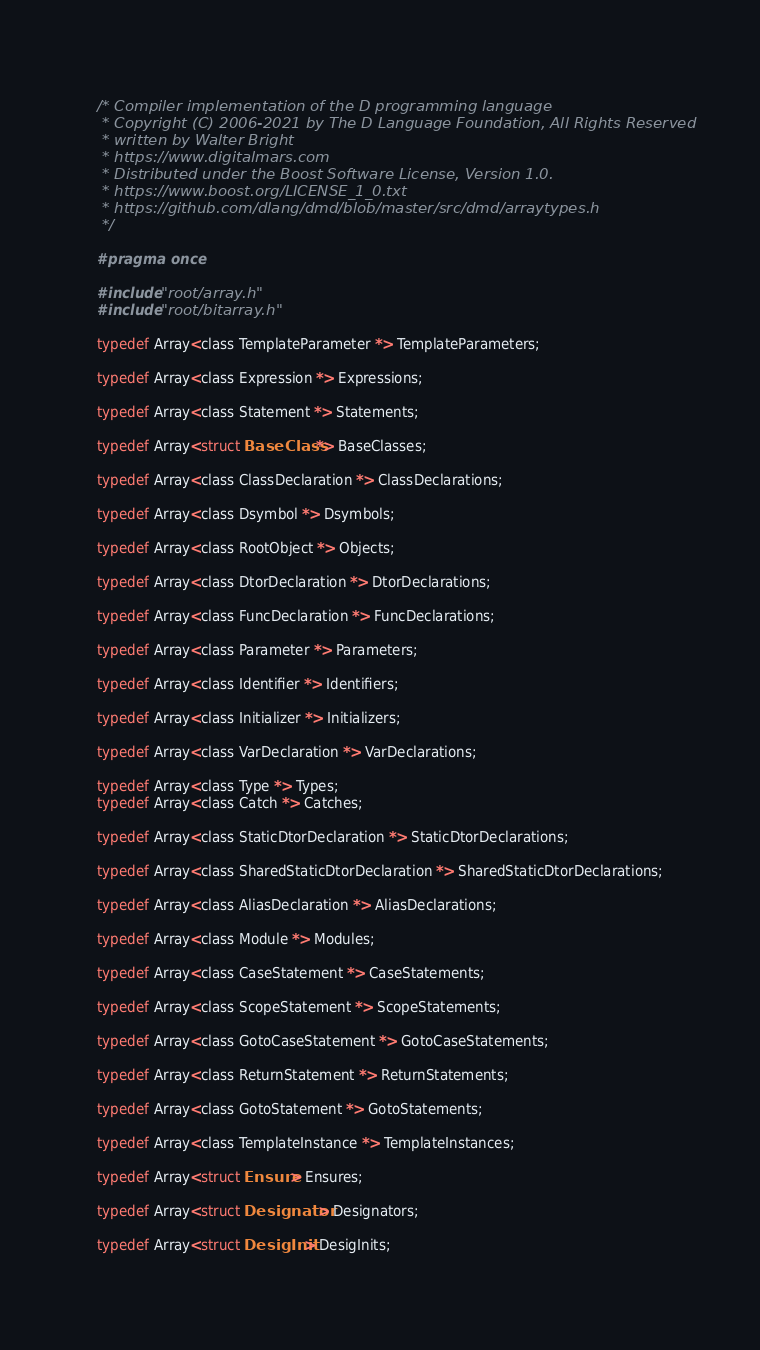Convert code to text. <code><loc_0><loc_0><loc_500><loc_500><_C_>
/* Compiler implementation of the D programming language
 * Copyright (C) 2006-2021 by The D Language Foundation, All Rights Reserved
 * written by Walter Bright
 * https://www.digitalmars.com
 * Distributed under the Boost Software License, Version 1.0.
 * https://www.boost.org/LICENSE_1_0.txt
 * https://github.com/dlang/dmd/blob/master/src/dmd/arraytypes.h
 */

#pragma once

#include "root/array.h"
#include "root/bitarray.h"

typedef Array<class TemplateParameter *> TemplateParameters;

typedef Array<class Expression *> Expressions;

typedef Array<class Statement *> Statements;

typedef Array<struct BaseClass *> BaseClasses;

typedef Array<class ClassDeclaration *> ClassDeclarations;

typedef Array<class Dsymbol *> Dsymbols;

typedef Array<class RootObject *> Objects;

typedef Array<class DtorDeclaration *> DtorDeclarations;

typedef Array<class FuncDeclaration *> FuncDeclarations;

typedef Array<class Parameter *> Parameters;

typedef Array<class Identifier *> Identifiers;

typedef Array<class Initializer *> Initializers;

typedef Array<class VarDeclaration *> VarDeclarations;

typedef Array<class Type *> Types;
typedef Array<class Catch *> Catches;

typedef Array<class StaticDtorDeclaration *> StaticDtorDeclarations;

typedef Array<class SharedStaticDtorDeclaration *> SharedStaticDtorDeclarations;

typedef Array<class AliasDeclaration *> AliasDeclarations;

typedef Array<class Module *> Modules;

typedef Array<class CaseStatement *> CaseStatements;

typedef Array<class ScopeStatement *> ScopeStatements;

typedef Array<class GotoCaseStatement *> GotoCaseStatements;

typedef Array<class ReturnStatement *> ReturnStatements;

typedef Array<class GotoStatement *> GotoStatements;

typedef Array<class TemplateInstance *> TemplateInstances;

typedef Array<struct Ensure> Ensures;

typedef Array<struct Designator> Designators;

typedef Array<struct DesigInit> DesigInits;

</code> 